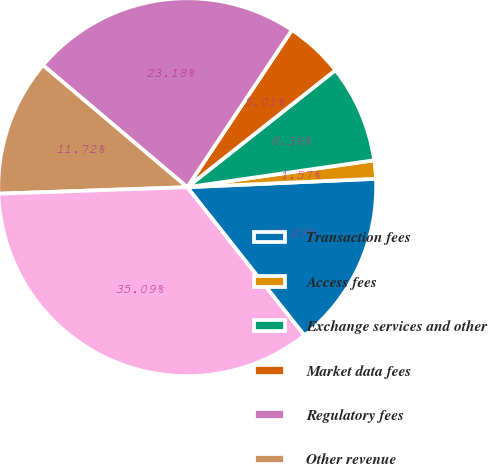Convert chart. <chart><loc_0><loc_0><loc_500><loc_500><pie_chart><fcel>Transaction fees<fcel>Access fees<fcel>Exchange services and other<fcel>Market data fees<fcel>Regulatory fees<fcel>Other revenue<fcel>Total operating revenues<nl><fcel>15.07%<fcel>1.57%<fcel>8.36%<fcel>5.01%<fcel>23.18%<fcel>11.72%<fcel>35.09%<nl></chart> 